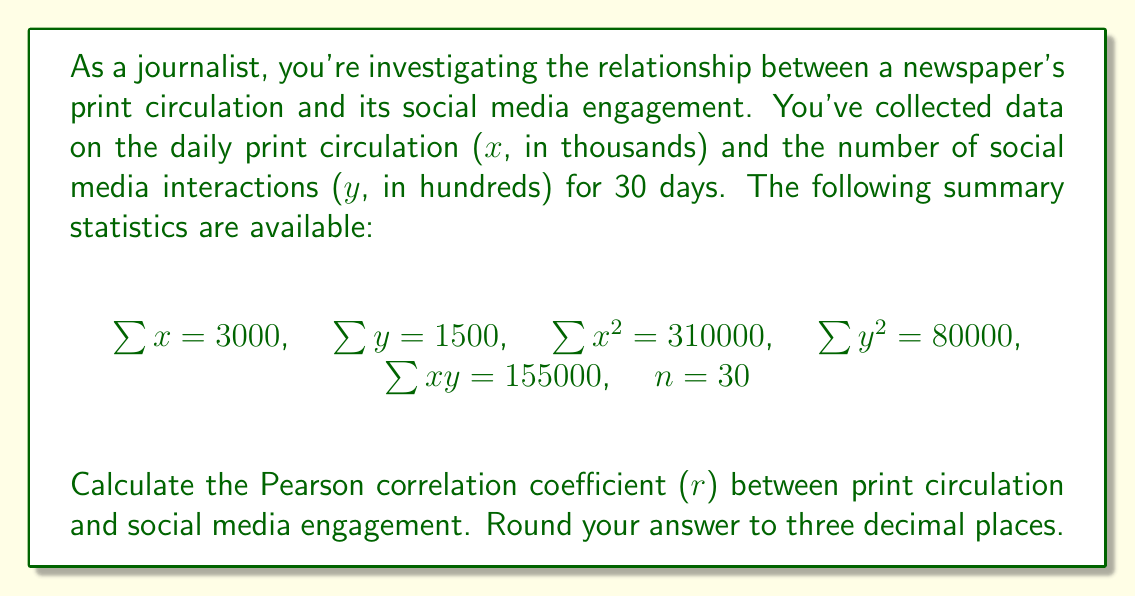Teach me how to tackle this problem. To calculate the Pearson correlation coefficient (r), we'll use the formula:

$$ r = \frac{n\sum xy - \sum x \sum y}{\sqrt{[n\sum x^2 - (\sum x)^2][n\sum y^2 - (\sum y)^2]}} $$

Let's substitute the given values:

$n = 30$
$\sum x = 3000$
$\sum y = 1500$
$\sum x^2 = 310000$
$\sum y^2 = 80000$
$\sum xy = 155000$

1. Calculate $n\sum xy$:
   $30 \times 155000 = 4650000$

2. Calculate $\sum x \sum y$:
   $3000 \times 1500 = 4500000$

3. Calculate the numerator:
   $4650000 - 4500000 = 150000$

4. Calculate $n\sum x^2$:
   $30 \times 310000 = 9300000$

5. Calculate $(\sum x)^2$:
   $3000^2 = 9000000$

6. Calculate $n\sum y^2$:
   $30 \times 80000 = 2400000$

7. Calculate $(\sum y)^2$:
   $1500^2 = 2250000$

8. Calculate the denominator:
   $\sqrt{[9300000 - 9000000][2400000 - 2250000]}$
   $= \sqrt{300000 \times 150000}$
   $= \sqrt{45000000000}$
   $= 212132.03$

9. Finally, calculate r:
   $r = \frac{150000}{212132.03} = 0.7071$

Rounding to three decimal places, we get 0.707.
Answer: 0.707 